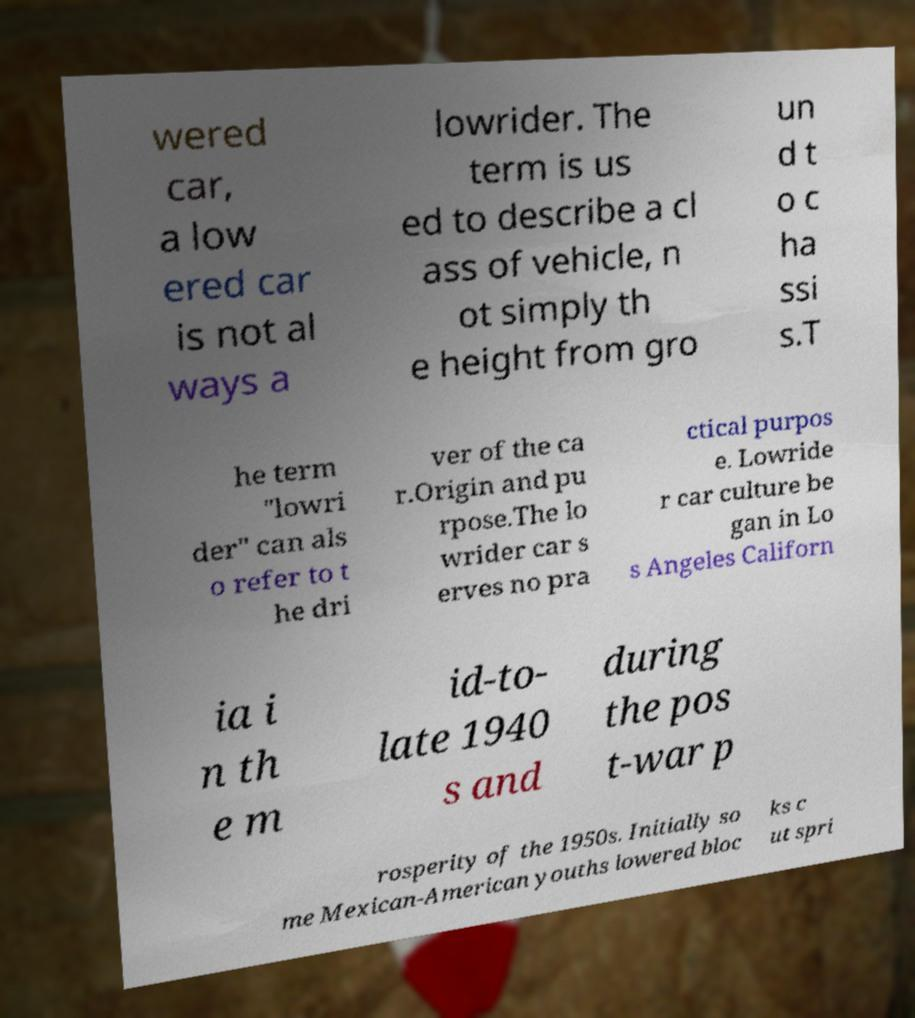Could you assist in decoding the text presented in this image and type it out clearly? wered car, a low ered car is not al ways a lowrider. The term is us ed to describe a cl ass of vehicle, n ot simply th e height from gro un d t o c ha ssi s.T he term "lowri der" can als o refer to t he dri ver of the ca r.Origin and pu rpose.The lo wrider car s erves no pra ctical purpos e. Lowride r car culture be gan in Lo s Angeles Californ ia i n th e m id-to- late 1940 s and during the pos t-war p rosperity of the 1950s. Initially so me Mexican-American youths lowered bloc ks c ut spri 